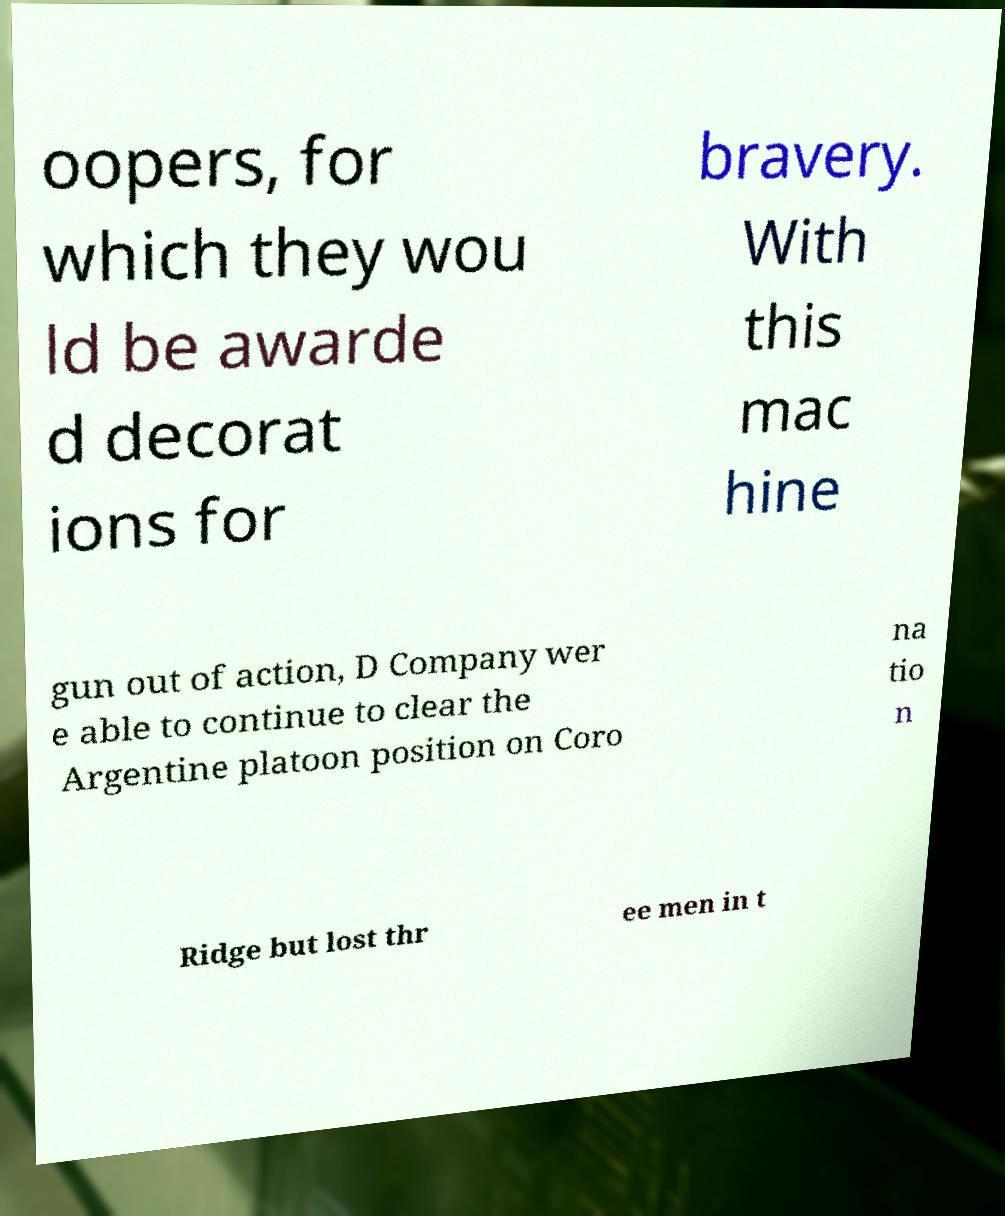For documentation purposes, I need the text within this image transcribed. Could you provide that? oopers, for which they wou ld be awarde d decorat ions for bravery. With this mac hine gun out of action, D Company wer e able to continue to clear the Argentine platoon position on Coro na tio n Ridge but lost thr ee men in t 